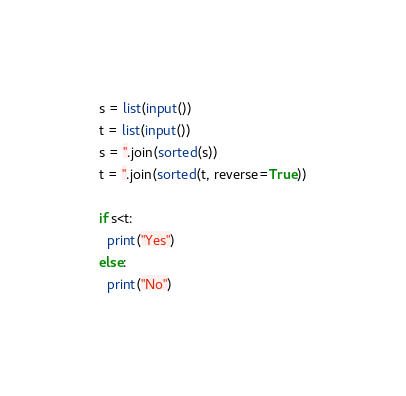Convert code to text. <code><loc_0><loc_0><loc_500><loc_500><_Python_>s = list(input())
t = list(input())
s = ''.join(sorted(s))
t = ''.join(sorted(t, reverse=True))

if s<t:
  print("Yes")
else:
  print("No")</code> 